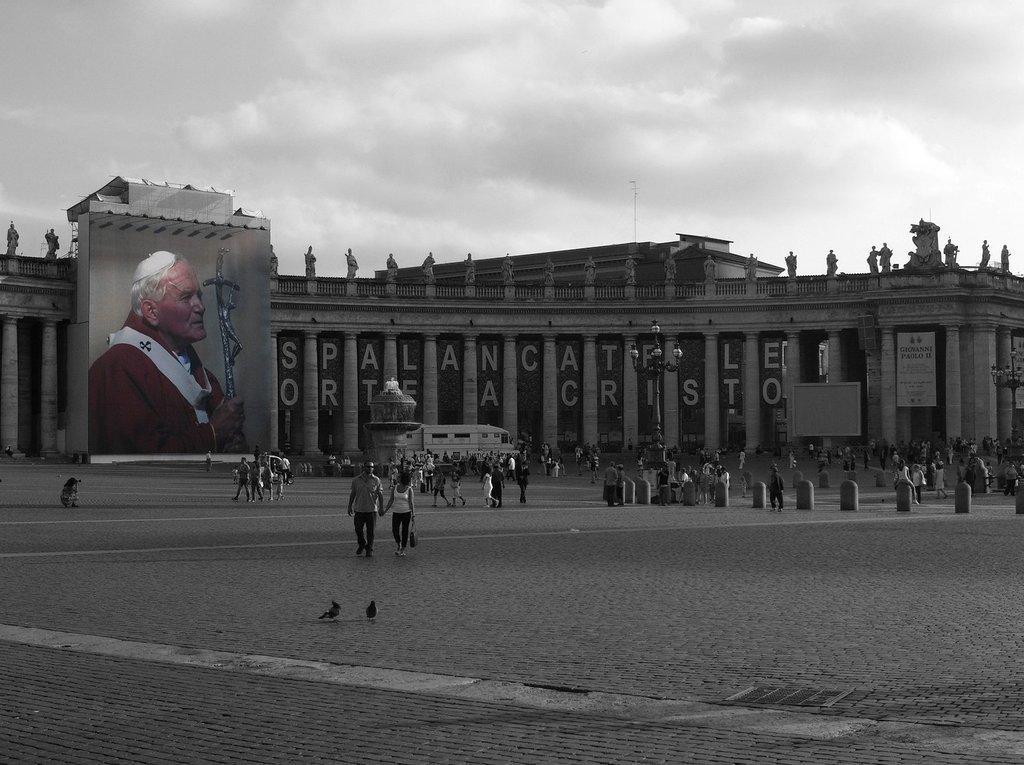Can you describe this image briefly? In this image I can see building and I can see a person image on the building , in front of the building I can see there are few persons walking on the road ,at the top I can see the sky and the sky is cloudy 